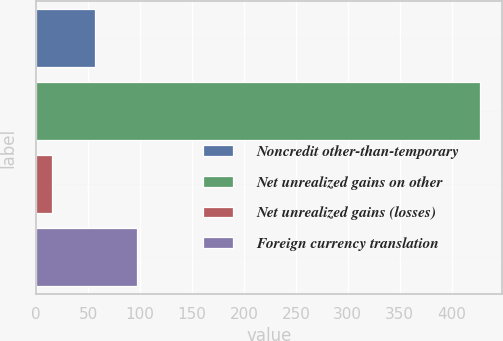Convert chart. <chart><loc_0><loc_0><loc_500><loc_500><bar_chart><fcel>Noncredit other-than-temporary<fcel>Net unrealized gains on other<fcel>Net unrealized gains (losses)<fcel>Foreign currency translation<nl><fcel>56.2<fcel>427<fcel>15<fcel>97.4<nl></chart> 